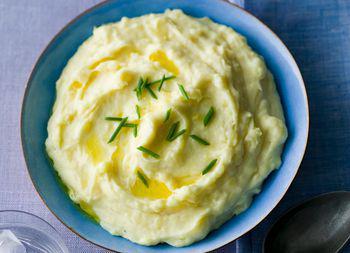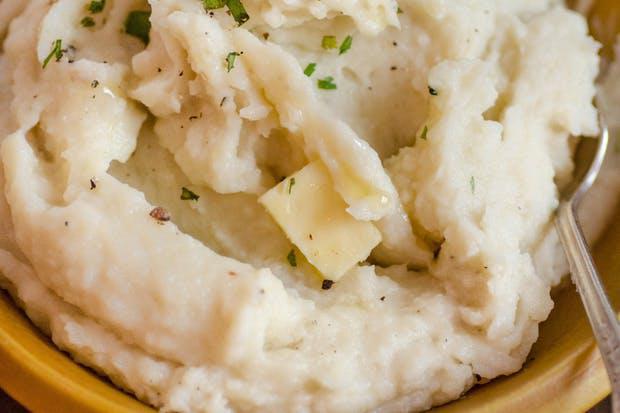The first image is the image on the left, the second image is the image on the right. Assess this claim about the two images: "One of the images shows  a bowl of mashed potatoes with a spoon in it.". Correct or not? Answer yes or no. Yes. 